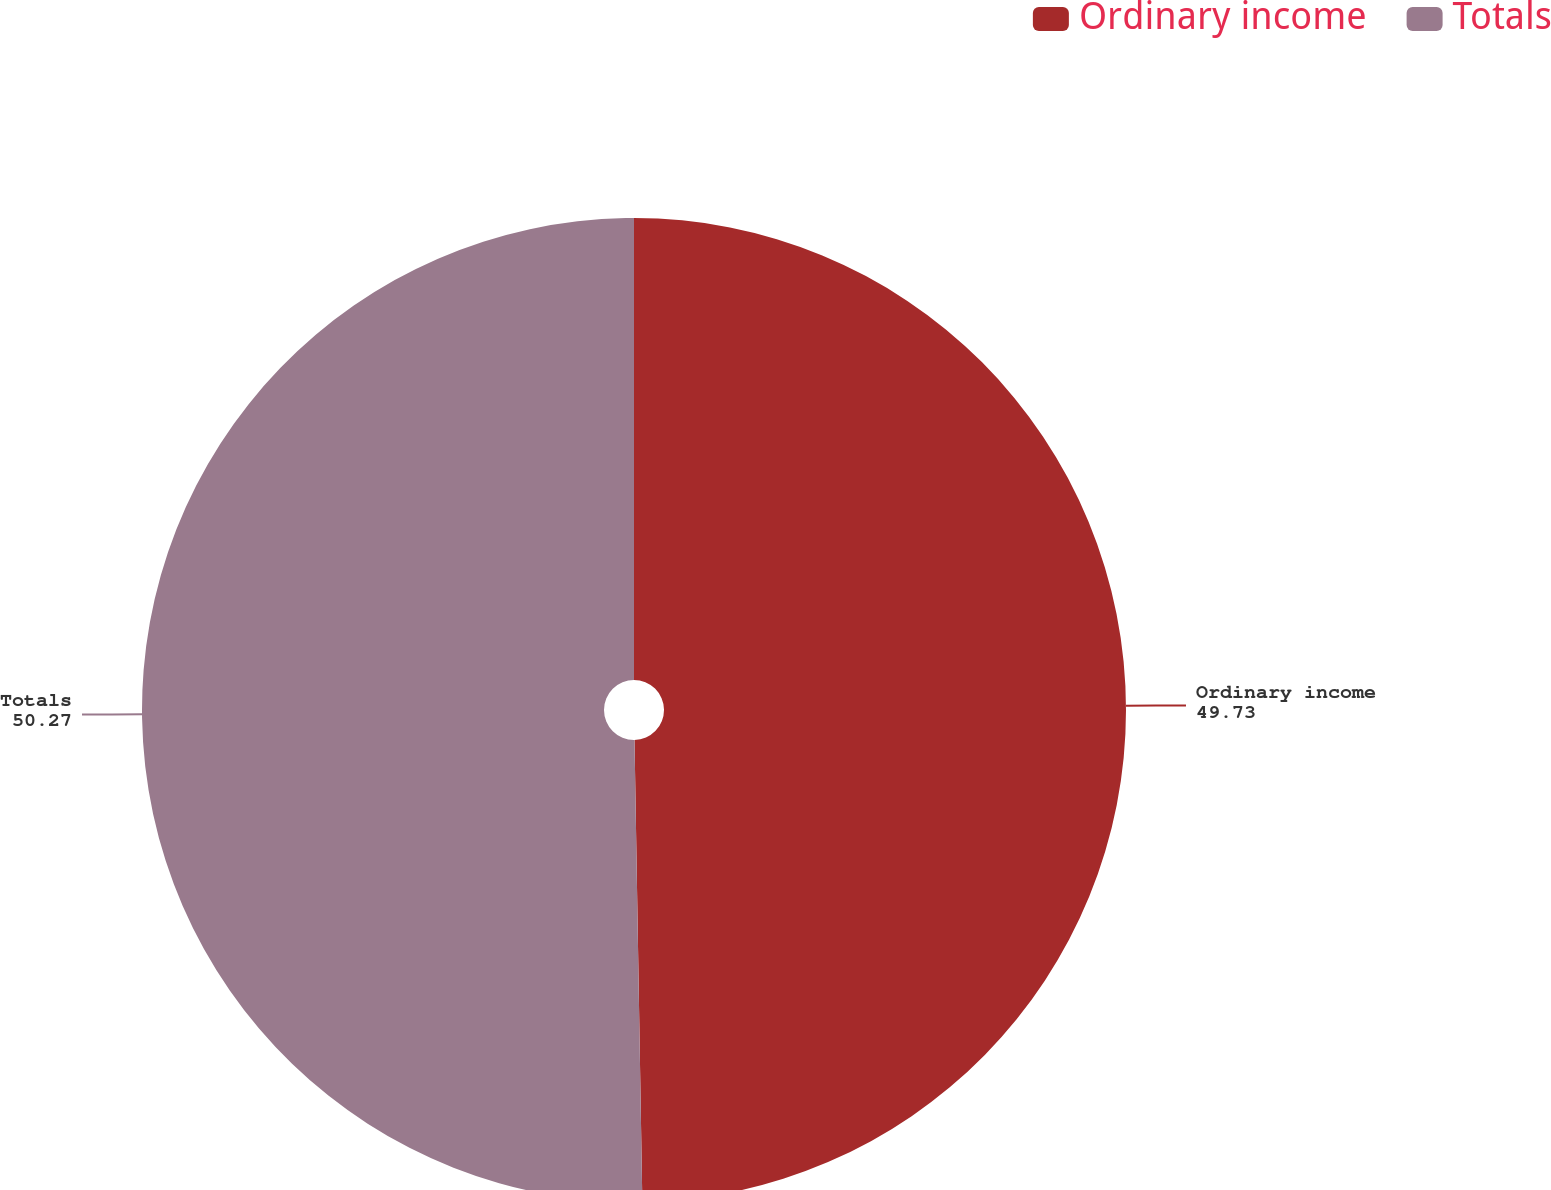Convert chart to OTSL. <chart><loc_0><loc_0><loc_500><loc_500><pie_chart><fcel>Ordinary income<fcel>Totals<nl><fcel>49.73%<fcel>50.27%<nl></chart> 